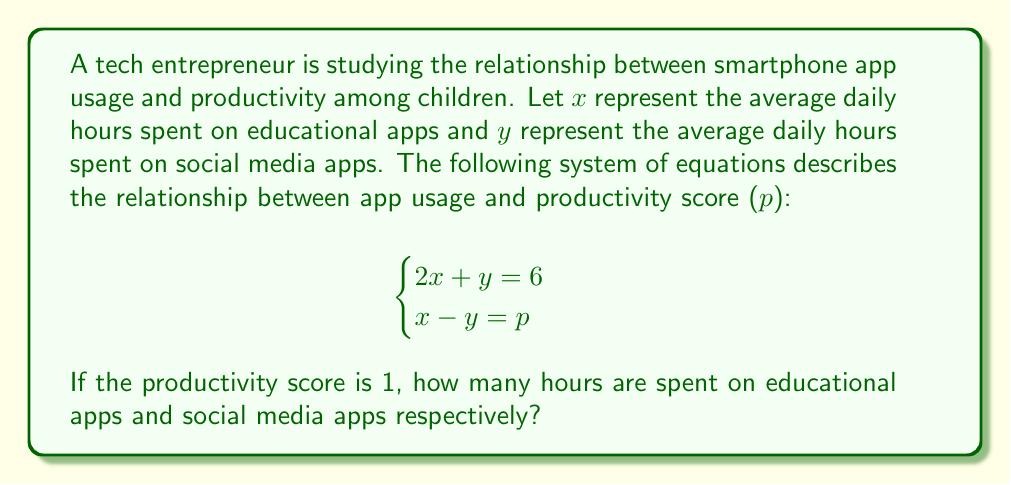Could you help me with this problem? Let's solve this system of equations step by step:

1) We are given that $p = 1$, so we can substitute this into the second equation:
   $$\begin{cases}
   2x + y = 6 \\
   x - y = 1
   \end{cases}$$

2) Now we have a system of two equations with two unknowns. We can solve this using the substitution method.

3) From the second equation, we can express $x$ in terms of $y$:
   $x = y + 1$

4) Substitute this into the first equation:
   $2(y + 1) + y = 6$

5) Simplify:
   $2y + 2 + y = 6$
   $3y + 2 = 6$

6) Solve for $y$:
   $3y = 4$
   $y = \frac{4}{3}$

7) Now that we know $y$, we can find $x$ using the equation from step 3:
   $x = y + 1 = \frac{4}{3} + 1 = \frac{4}{3} + \frac{3}{3} = \frac{7}{3}$

Therefore, $x = \frac{7}{3}$ hours are spent on educational apps, and $y = \frac{4}{3}$ hours are spent on social media apps.
Answer: $x = \frac{7}{3}$, $y = \frac{4}{3}$ 